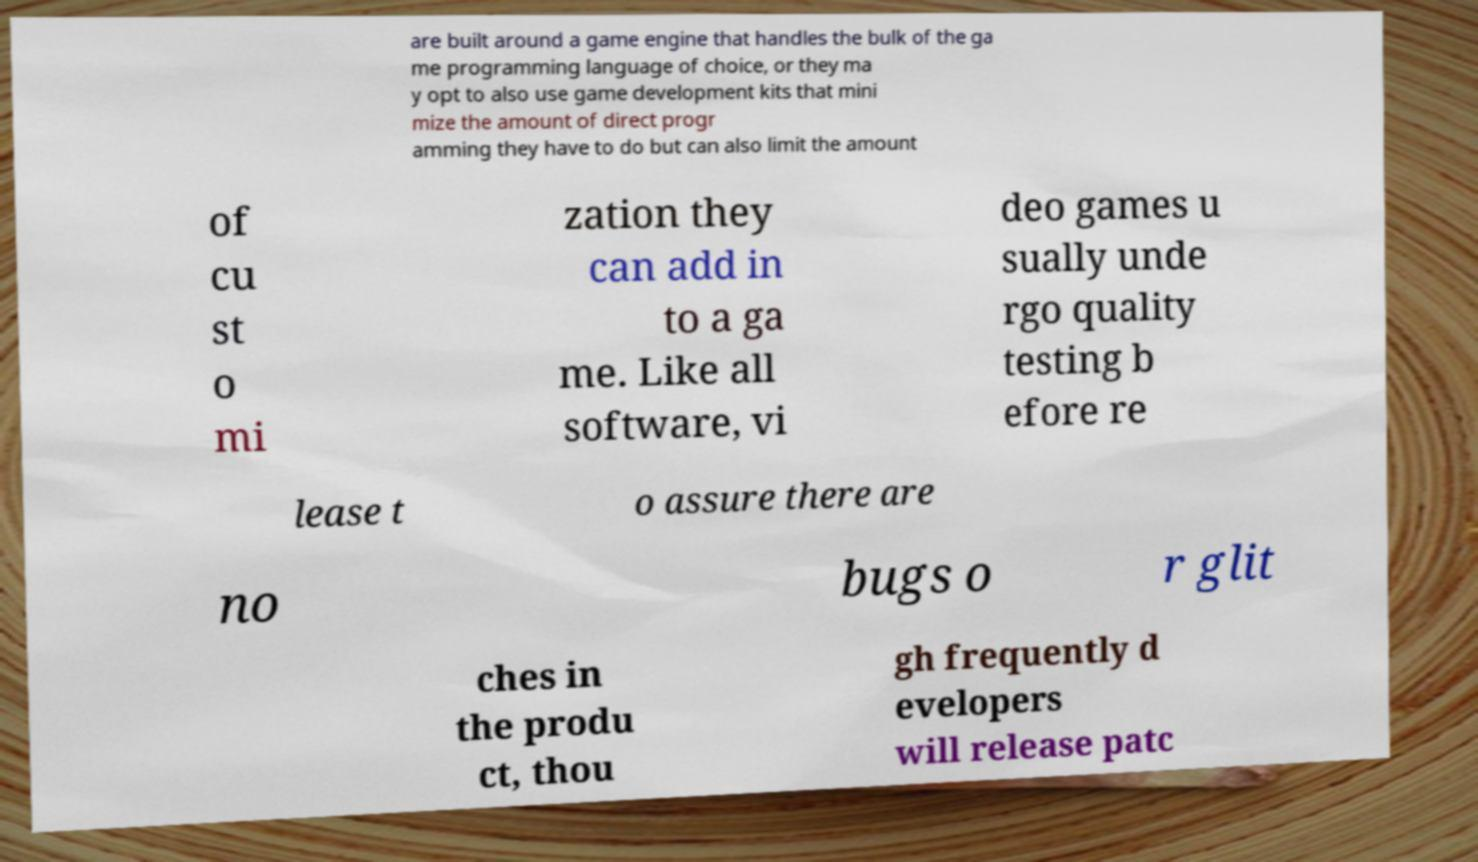Could you extract and type out the text from this image? are built around a game engine that handles the bulk of the ga me programming language of choice, or they ma y opt to also use game development kits that mini mize the amount of direct progr amming they have to do but can also limit the amount of cu st o mi zation they can add in to a ga me. Like all software, vi deo games u sually unde rgo quality testing b efore re lease t o assure there are no bugs o r glit ches in the produ ct, thou gh frequently d evelopers will release patc 